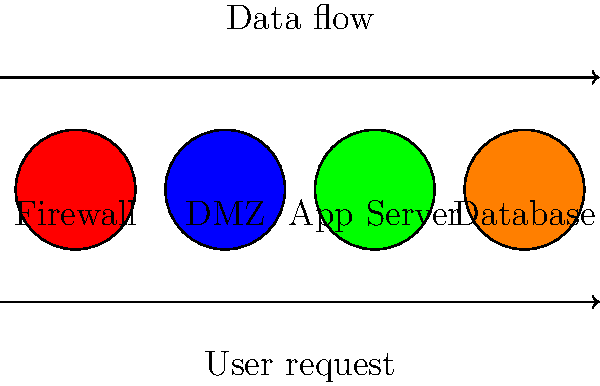In designing a secure network architecture for your late-night coffee shop's customer data protection, which component should be placed between the public internet and the internal network to filter incoming traffic? To design a secure network architecture for customer data protection in your late-night coffee shop, consider the following steps:

1. Identify the components: 
   - Firewall
   - DMZ (Demilitarized Zone)
   - Application Server
   - Database Server

2. Understand the data flow:
   User request → Firewall → DMZ → Application Server → Database

3. Component placement:
   a) Firewall: Acts as the first line of defense against external threats.
   b) DMZ: Hosts public-facing services like web servers.
   c) Application Server: Processes user requests and interacts with the database.
   d) Database: Stores sensitive customer data in the most secure zone.

4. Firewall functionality:
   - Filters incoming and outgoing traffic
   - Blocks unauthorized access attempts
   - Implements access control policies

5. DMZ benefits:
   - Adds an extra layer of security
   - Isolates public-facing services from internal network

6. Application and Database server security:
   - Placed behind the DMZ for additional protection
   - Implement encryption and access controls

The firewall should be placed between the public internet and the internal network to filter incoming traffic, acting as the first line of defense in protecting your customer data.
Answer: Firewall 